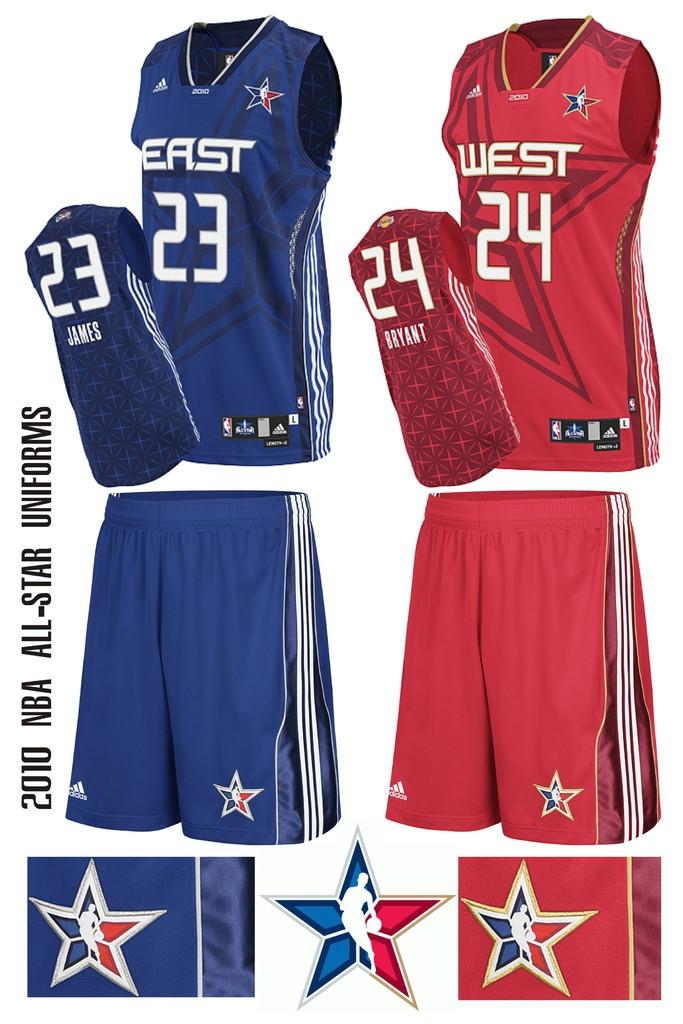What type of clothing is visible in the foreground of the image? There are shorts and T-shirts in the foreground of the image. What colors are the logos on the clothing? The logos are in blue and red colors in the foreground of the image. What type of basket is used for the operation in the image? There is no basket or operation present in the image; it features shorts and T-shirts with logos in blue and red colors. 